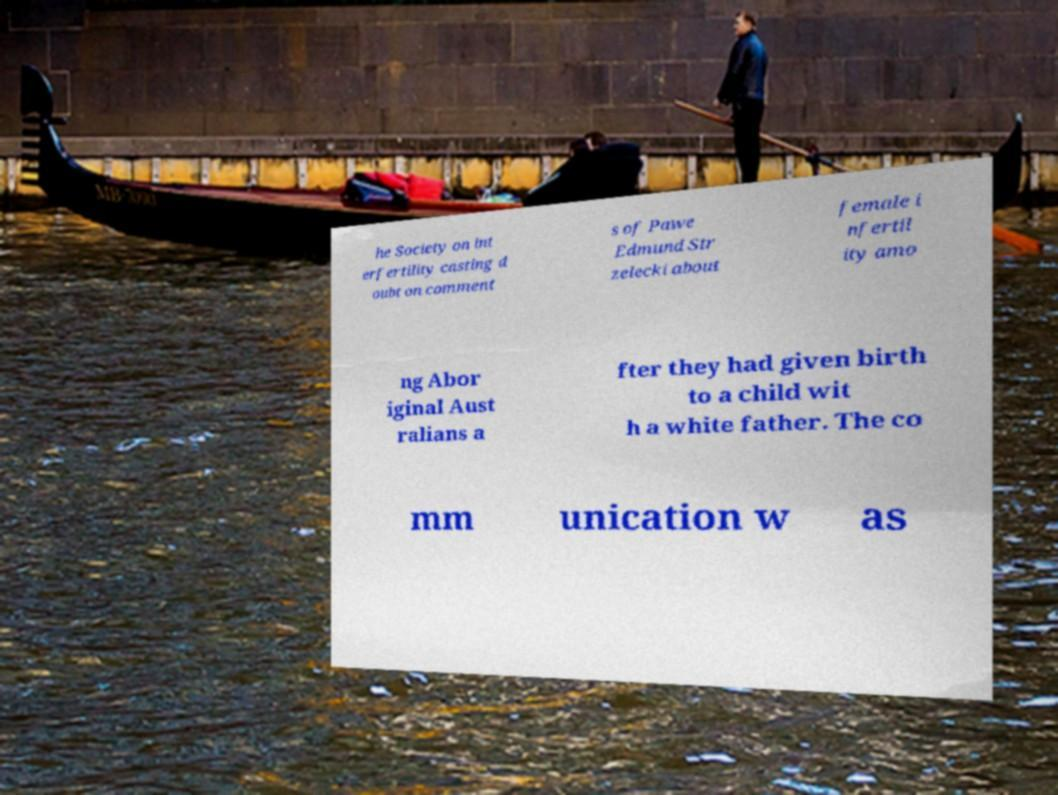For documentation purposes, I need the text within this image transcribed. Could you provide that? he Society on int erfertility casting d oubt on comment s of Pawe Edmund Str zelecki about female i nfertil ity amo ng Abor iginal Aust ralians a fter they had given birth to a child wit h a white father. The co mm unication w as 